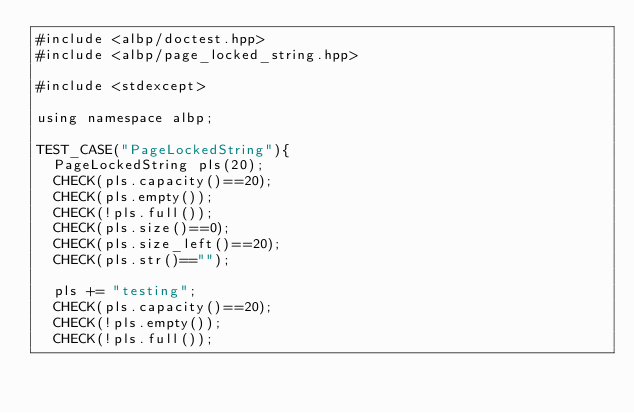<code> <loc_0><loc_0><loc_500><loc_500><_Cuda_>#include <albp/doctest.hpp>
#include <albp/page_locked_string.hpp>

#include <stdexcept>

using namespace albp;

TEST_CASE("PageLockedString"){
  PageLockedString pls(20);
  CHECK(pls.capacity()==20);
  CHECK(pls.empty());
  CHECK(!pls.full());
  CHECK(pls.size()==0);
  CHECK(pls.size_left()==20);
  CHECK(pls.str()=="");

  pls += "testing";
  CHECK(pls.capacity()==20);
  CHECK(!pls.empty());
  CHECK(!pls.full());</code> 